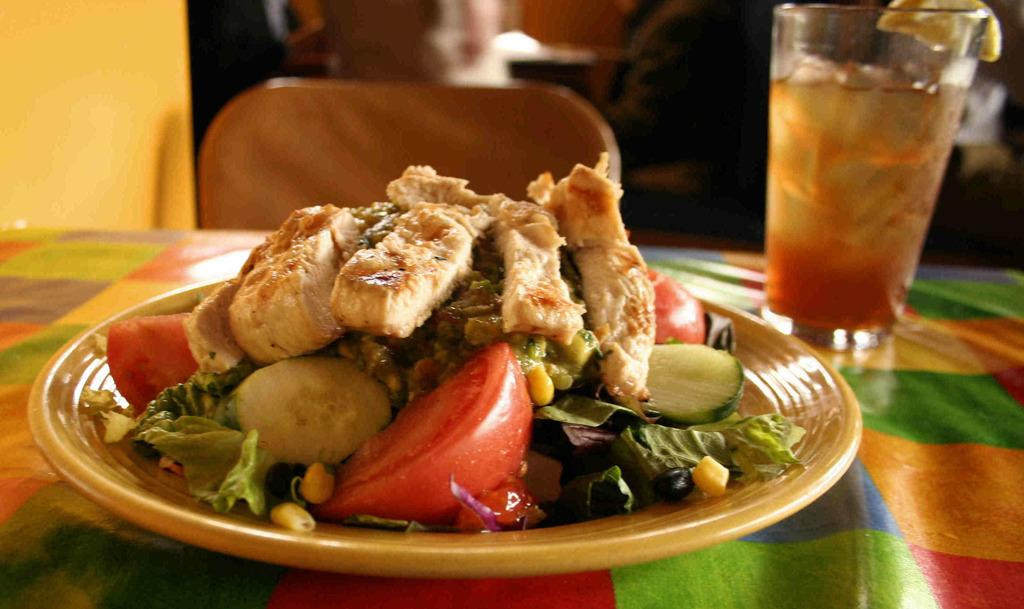What types of food are on the plate in the image? There are veggies and meat on the plate in the image. What is the drink in the glass on the side? The drink in the glass on the side is not specified in the image. What is the purpose of the chair in the image? The chair in the image is for sitting. What type of soda is being served in the pig's form in the image? There is no soda or pig present in the image. 